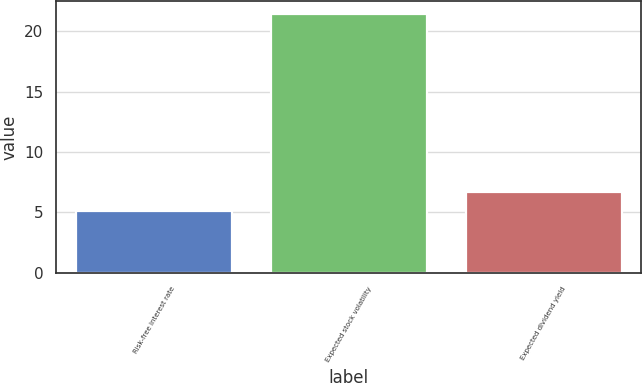Convert chart to OTSL. <chart><loc_0><loc_0><loc_500><loc_500><bar_chart><fcel>Risk-free interest rate<fcel>Expected stock volatility<fcel>Expected dividend yield<nl><fcel>5.08<fcel>21.43<fcel>6.71<nl></chart> 